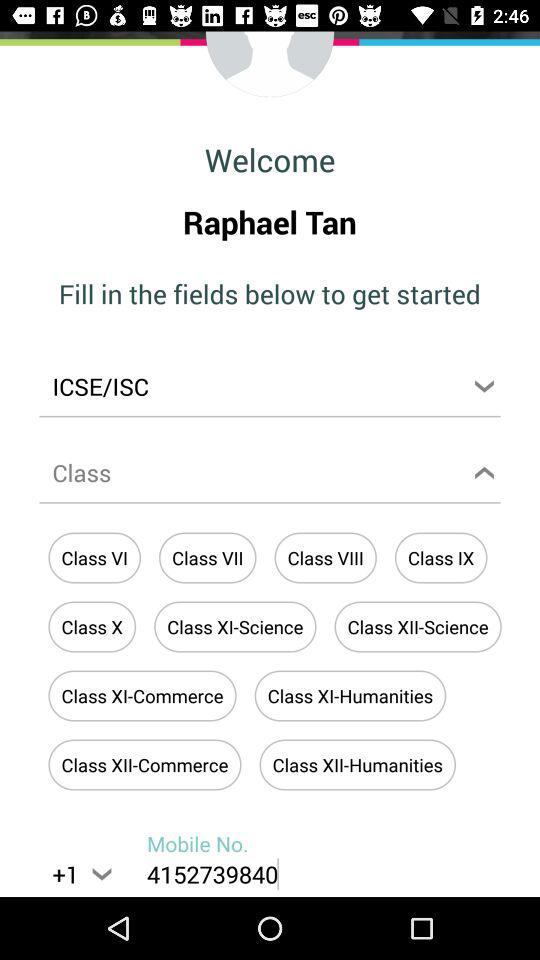What is the selected country code? The selected country code is +1. 